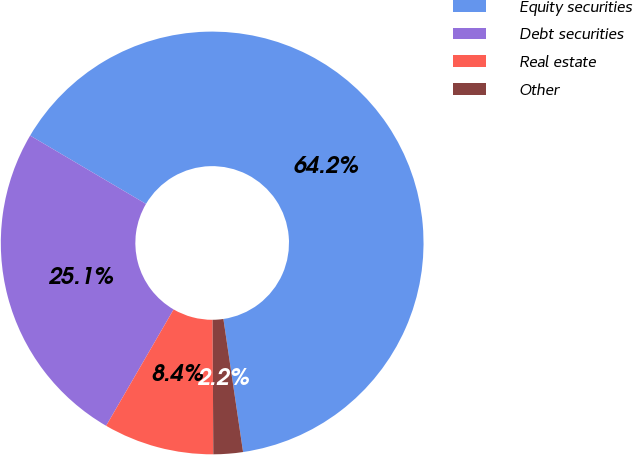Convert chart to OTSL. <chart><loc_0><loc_0><loc_500><loc_500><pie_chart><fcel>Equity securities<fcel>Debt securities<fcel>Real estate<fcel>Other<nl><fcel>64.19%<fcel>25.12%<fcel>8.45%<fcel>2.25%<nl></chart> 